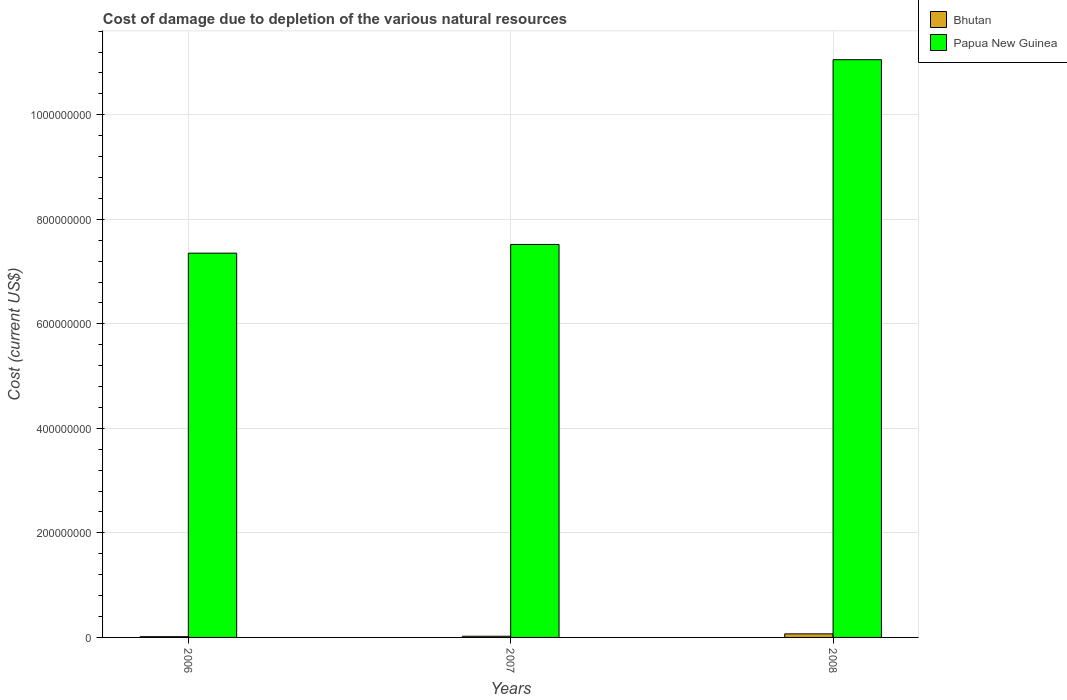How many different coloured bars are there?
Your response must be concise. 2. How many groups of bars are there?
Give a very brief answer. 3. What is the label of the 1st group of bars from the left?
Keep it short and to the point. 2006. What is the cost of damage caused due to the depletion of various natural resources in Papua New Guinea in 2006?
Ensure brevity in your answer.  7.35e+08. Across all years, what is the maximum cost of damage caused due to the depletion of various natural resources in Bhutan?
Give a very brief answer. 6.82e+06. Across all years, what is the minimum cost of damage caused due to the depletion of various natural resources in Papua New Guinea?
Your answer should be very brief. 7.35e+08. In which year was the cost of damage caused due to the depletion of various natural resources in Papua New Guinea minimum?
Your answer should be very brief. 2006. What is the total cost of damage caused due to the depletion of various natural resources in Papua New Guinea in the graph?
Provide a short and direct response. 2.59e+09. What is the difference between the cost of damage caused due to the depletion of various natural resources in Papua New Guinea in 2006 and that in 2008?
Your answer should be very brief. -3.70e+08. What is the difference between the cost of damage caused due to the depletion of various natural resources in Papua New Guinea in 2008 and the cost of damage caused due to the depletion of various natural resources in Bhutan in 2007?
Provide a succinct answer. 1.10e+09. What is the average cost of damage caused due to the depletion of various natural resources in Papua New Guinea per year?
Your response must be concise. 8.64e+08. In the year 2008, what is the difference between the cost of damage caused due to the depletion of various natural resources in Bhutan and cost of damage caused due to the depletion of various natural resources in Papua New Guinea?
Make the answer very short. -1.10e+09. In how many years, is the cost of damage caused due to the depletion of various natural resources in Bhutan greater than 880000000 US$?
Provide a succinct answer. 0. What is the ratio of the cost of damage caused due to the depletion of various natural resources in Bhutan in 2006 to that in 2007?
Your answer should be very brief. 0.63. Is the cost of damage caused due to the depletion of various natural resources in Bhutan in 2006 less than that in 2007?
Offer a terse response. Yes. What is the difference between the highest and the second highest cost of damage caused due to the depletion of various natural resources in Papua New Guinea?
Make the answer very short. 3.53e+08. What is the difference between the highest and the lowest cost of damage caused due to the depletion of various natural resources in Papua New Guinea?
Your response must be concise. 3.70e+08. In how many years, is the cost of damage caused due to the depletion of various natural resources in Bhutan greater than the average cost of damage caused due to the depletion of various natural resources in Bhutan taken over all years?
Your answer should be compact. 1. What does the 2nd bar from the left in 2006 represents?
Offer a terse response. Papua New Guinea. What does the 1st bar from the right in 2006 represents?
Your answer should be compact. Papua New Guinea. How many bars are there?
Your answer should be compact. 6. How many years are there in the graph?
Ensure brevity in your answer.  3. Does the graph contain grids?
Keep it short and to the point. Yes. How many legend labels are there?
Your answer should be compact. 2. How are the legend labels stacked?
Your answer should be very brief. Vertical. What is the title of the graph?
Keep it short and to the point. Cost of damage due to depletion of the various natural resources. What is the label or title of the Y-axis?
Your response must be concise. Cost (current US$). What is the Cost (current US$) of Bhutan in 2006?
Your response must be concise. 1.41e+06. What is the Cost (current US$) of Papua New Guinea in 2006?
Ensure brevity in your answer.  7.35e+08. What is the Cost (current US$) in Bhutan in 2007?
Provide a short and direct response. 2.24e+06. What is the Cost (current US$) in Papua New Guinea in 2007?
Make the answer very short. 7.52e+08. What is the Cost (current US$) of Bhutan in 2008?
Ensure brevity in your answer.  6.82e+06. What is the Cost (current US$) of Papua New Guinea in 2008?
Your response must be concise. 1.11e+09. Across all years, what is the maximum Cost (current US$) of Bhutan?
Provide a succinct answer. 6.82e+06. Across all years, what is the maximum Cost (current US$) of Papua New Guinea?
Provide a short and direct response. 1.11e+09. Across all years, what is the minimum Cost (current US$) of Bhutan?
Your response must be concise. 1.41e+06. Across all years, what is the minimum Cost (current US$) of Papua New Guinea?
Provide a short and direct response. 7.35e+08. What is the total Cost (current US$) in Bhutan in the graph?
Keep it short and to the point. 1.05e+07. What is the total Cost (current US$) in Papua New Guinea in the graph?
Provide a succinct answer. 2.59e+09. What is the difference between the Cost (current US$) in Bhutan in 2006 and that in 2007?
Your answer should be very brief. -8.29e+05. What is the difference between the Cost (current US$) in Papua New Guinea in 2006 and that in 2007?
Your answer should be very brief. -1.67e+07. What is the difference between the Cost (current US$) in Bhutan in 2006 and that in 2008?
Make the answer very short. -5.41e+06. What is the difference between the Cost (current US$) of Papua New Guinea in 2006 and that in 2008?
Your response must be concise. -3.70e+08. What is the difference between the Cost (current US$) in Bhutan in 2007 and that in 2008?
Your answer should be compact. -4.58e+06. What is the difference between the Cost (current US$) in Papua New Guinea in 2007 and that in 2008?
Ensure brevity in your answer.  -3.53e+08. What is the difference between the Cost (current US$) in Bhutan in 2006 and the Cost (current US$) in Papua New Guinea in 2007?
Ensure brevity in your answer.  -7.50e+08. What is the difference between the Cost (current US$) in Bhutan in 2006 and the Cost (current US$) in Papua New Guinea in 2008?
Keep it short and to the point. -1.10e+09. What is the difference between the Cost (current US$) in Bhutan in 2007 and the Cost (current US$) in Papua New Guinea in 2008?
Offer a very short reply. -1.10e+09. What is the average Cost (current US$) in Bhutan per year?
Offer a terse response. 3.49e+06. What is the average Cost (current US$) of Papua New Guinea per year?
Provide a succinct answer. 8.64e+08. In the year 2006, what is the difference between the Cost (current US$) of Bhutan and Cost (current US$) of Papua New Guinea?
Your answer should be compact. -7.34e+08. In the year 2007, what is the difference between the Cost (current US$) in Bhutan and Cost (current US$) in Papua New Guinea?
Your answer should be very brief. -7.50e+08. In the year 2008, what is the difference between the Cost (current US$) of Bhutan and Cost (current US$) of Papua New Guinea?
Provide a short and direct response. -1.10e+09. What is the ratio of the Cost (current US$) in Bhutan in 2006 to that in 2007?
Give a very brief answer. 0.63. What is the ratio of the Cost (current US$) in Papua New Guinea in 2006 to that in 2007?
Offer a terse response. 0.98. What is the ratio of the Cost (current US$) in Bhutan in 2006 to that in 2008?
Provide a succinct answer. 0.21. What is the ratio of the Cost (current US$) of Papua New Guinea in 2006 to that in 2008?
Ensure brevity in your answer.  0.67. What is the ratio of the Cost (current US$) in Bhutan in 2007 to that in 2008?
Offer a terse response. 0.33. What is the ratio of the Cost (current US$) in Papua New Guinea in 2007 to that in 2008?
Your response must be concise. 0.68. What is the difference between the highest and the second highest Cost (current US$) of Bhutan?
Provide a short and direct response. 4.58e+06. What is the difference between the highest and the second highest Cost (current US$) in Papua New Guinea?
Ensure brevity in your answer.  3.53e+08. What is the difference between the highest and the lowest Cost (current US$) in Bhutan?
Give a very brief answer. 5.41e+06. What is the difference between the highest and the lowest Cost (current US$) in Papua New Guinea?
Offer a terse response. 3.70e+08. 